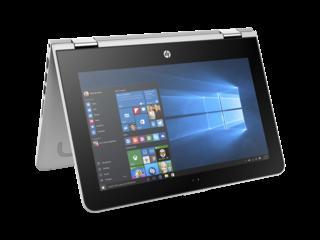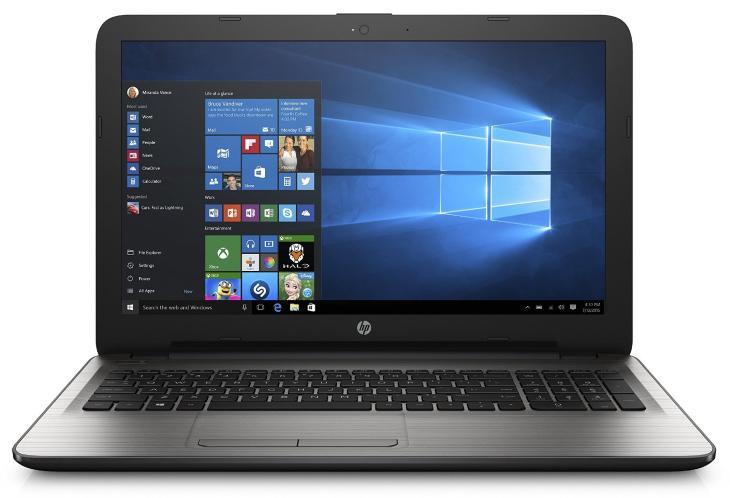The first image is the image on the left, the second image is the image on the right. Examine the images to the left and right. Is the description "All laptops in the paired pictures have the same screen image." accurate? Answer yes or no. Yes. 